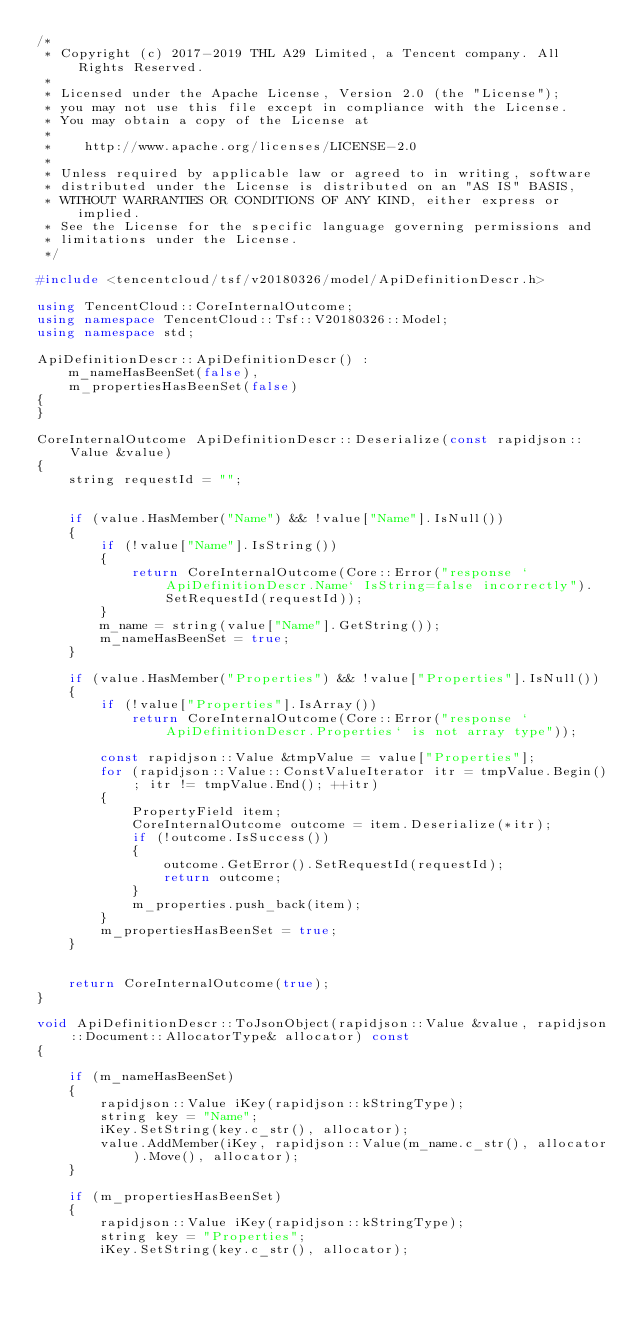<code> <loc_0><loc_0><loc_500><loc_500><_C++_>/*
 * Copyright (c) 2017-2019 THL A29 Limited, a Tencent company. All Rights Reserved.
 *
 * Licensed under the Apache License, Version 2.0 (the "License");
 * you may not use this file except in compliance with the License.
 * You may obtain a copy of the License at
 *
 *    http://www.apache.org/licenses/LICENSE-2.0
 *
 * Unless required by applicable law or agreed to in writing, software
 * distributed under the License is distributed on an "AS IS" BASIS,
 * WITHOUT WARRANTIES OR CONDITIONS OF ANY KIND, either express or implied.
 * See the License for the specific language governing permissions and
 * limitations under the License.
 */

#include <tencentcloud/tsf/v20180326/model/ApiDefinitionDescr.h>

using TencentCloud::CoreInternalOutcome;
using namespace TencentCloud::Tsf::V20180326::Model;
using namespace std;

ApiDefinitionDescr::ApiDefinitionDescr() :
    m_nameHasBeenSet(false),
    m_propertiesHasBeenSet(false)
{
}

CoreInternalOutcome ApiDefinitionDescr::Deserialize(const rapidjson::Value &value)
{
    string requestId = "";


    if (value.HasMember("Name") && !value["Name"].IsNull())
    {
        if (!value["Name"].IsString())
        {
            return CoreInternalOutcome(Core::Error("response `ApiDefinitionDescr.Name` IsString=false incorrectly").SetRequestId(requestId));
        }
        m_name = string(value["Name"].GetString());
        m_nameHasBeenSet = true;
    }

    if (value.HasMember("Properties") && !value["Properties"].IsNull())
    {
        if (!value["Properties"].IsArray())
            return CoreInternalOutcome(Core::Error("response `ApiDefinitionDescr.Properties` is not array type"));

        const rapidjson::Value &tmpValue = value["Properties"];
        for (rapidjson::Value::ConstValueIterator itr = tmpValue.Begin(); itr != tmpValue.End(); ++itr)
        {
            PropertyField item;
            CoreInternalOutcome outcome = item.Deserialize(*itr);
            if (!outcome.IsSuccess())
            {
                outcome.GetError().SetRequestId(requestId);
                return outcome;
            }
            m_properties.push_back(item);
        }
        m_propertiesHasBeenSet = true;
    }


    return CoreInternalOutcome(true);
}

void ApiDefinitionDescr::ToJsonObject(rapidjson::Value &value, rapidjson::Document::AllocatorType& allocator) const
{

    if (m_nameHasBeenSet)
    {
        rapidjson::Value iKey(rapidjson::kStringType);
        string key = "Name";
        iKey.SetString(key.c_str(), allocator);
        value.AddMember(iKey, rapidjson::Value(m_name.c_str(), allocator).Move(), allocator);
    }

    if (m_propertiesHasBeenSet)
    {
        rapidjson::Value iKey(rapidjson::kStringType);
        string key = "Properties";
        iKey.SetString(key.c_str(), allocator);</code> 